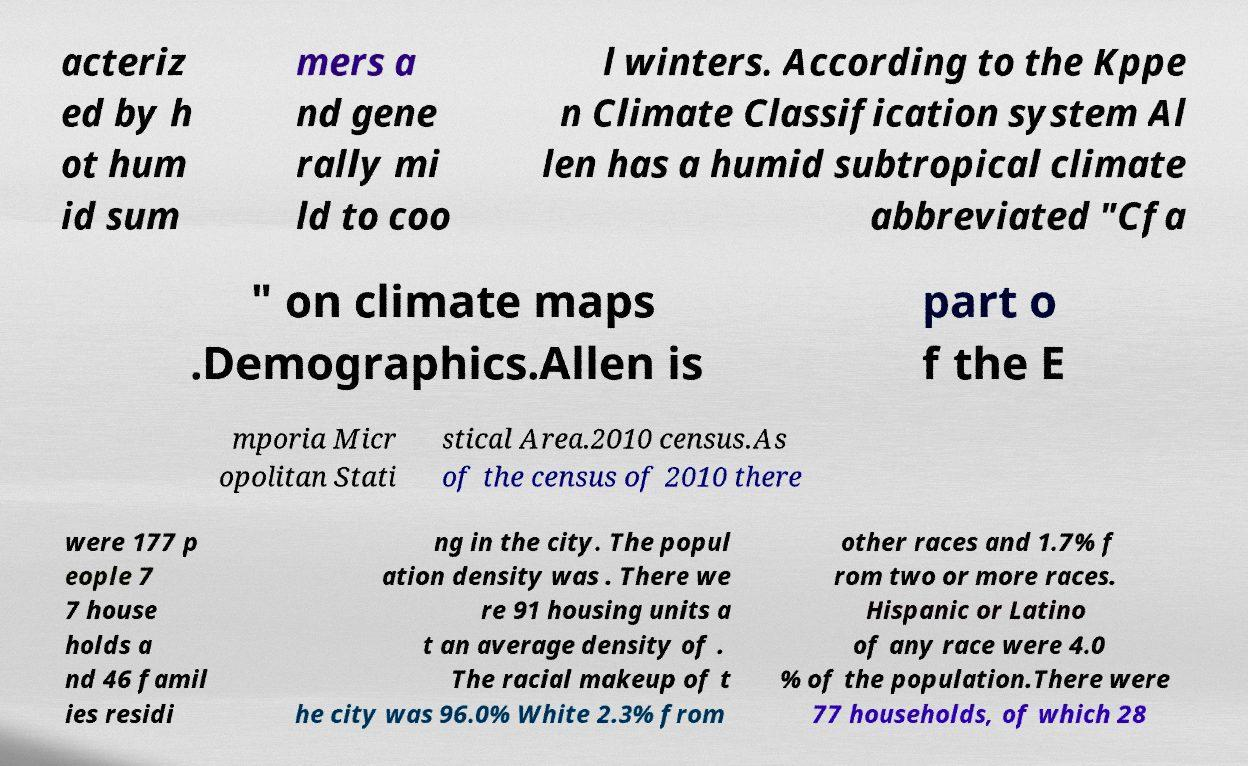Please identify and transcribe the text found in this image. acteriz ed by h ot hum id sum mers a nd gene rally mi ld to coo l winters. According to the Kppe n Climate Classification system Al len has a humid subtropical climate abbreviated "Cfa " on climate maps .Demographics.Allen is part o f the E mporia Micr opolitan Stati stical Area.2010 census.As of the census of 2010 there were 177 p eople 7 7 house holds a nd 46 famil ies residi ng in the city. The popul ation density was . There we re 91 housing units a t an average density of . The racial makeup of t he city was 96.0% White 2.3% from other races and 1.7% f rom two or more races. Hispanic or Latino of any race were 4.0 % of the population.There were 77 households, of which 28 